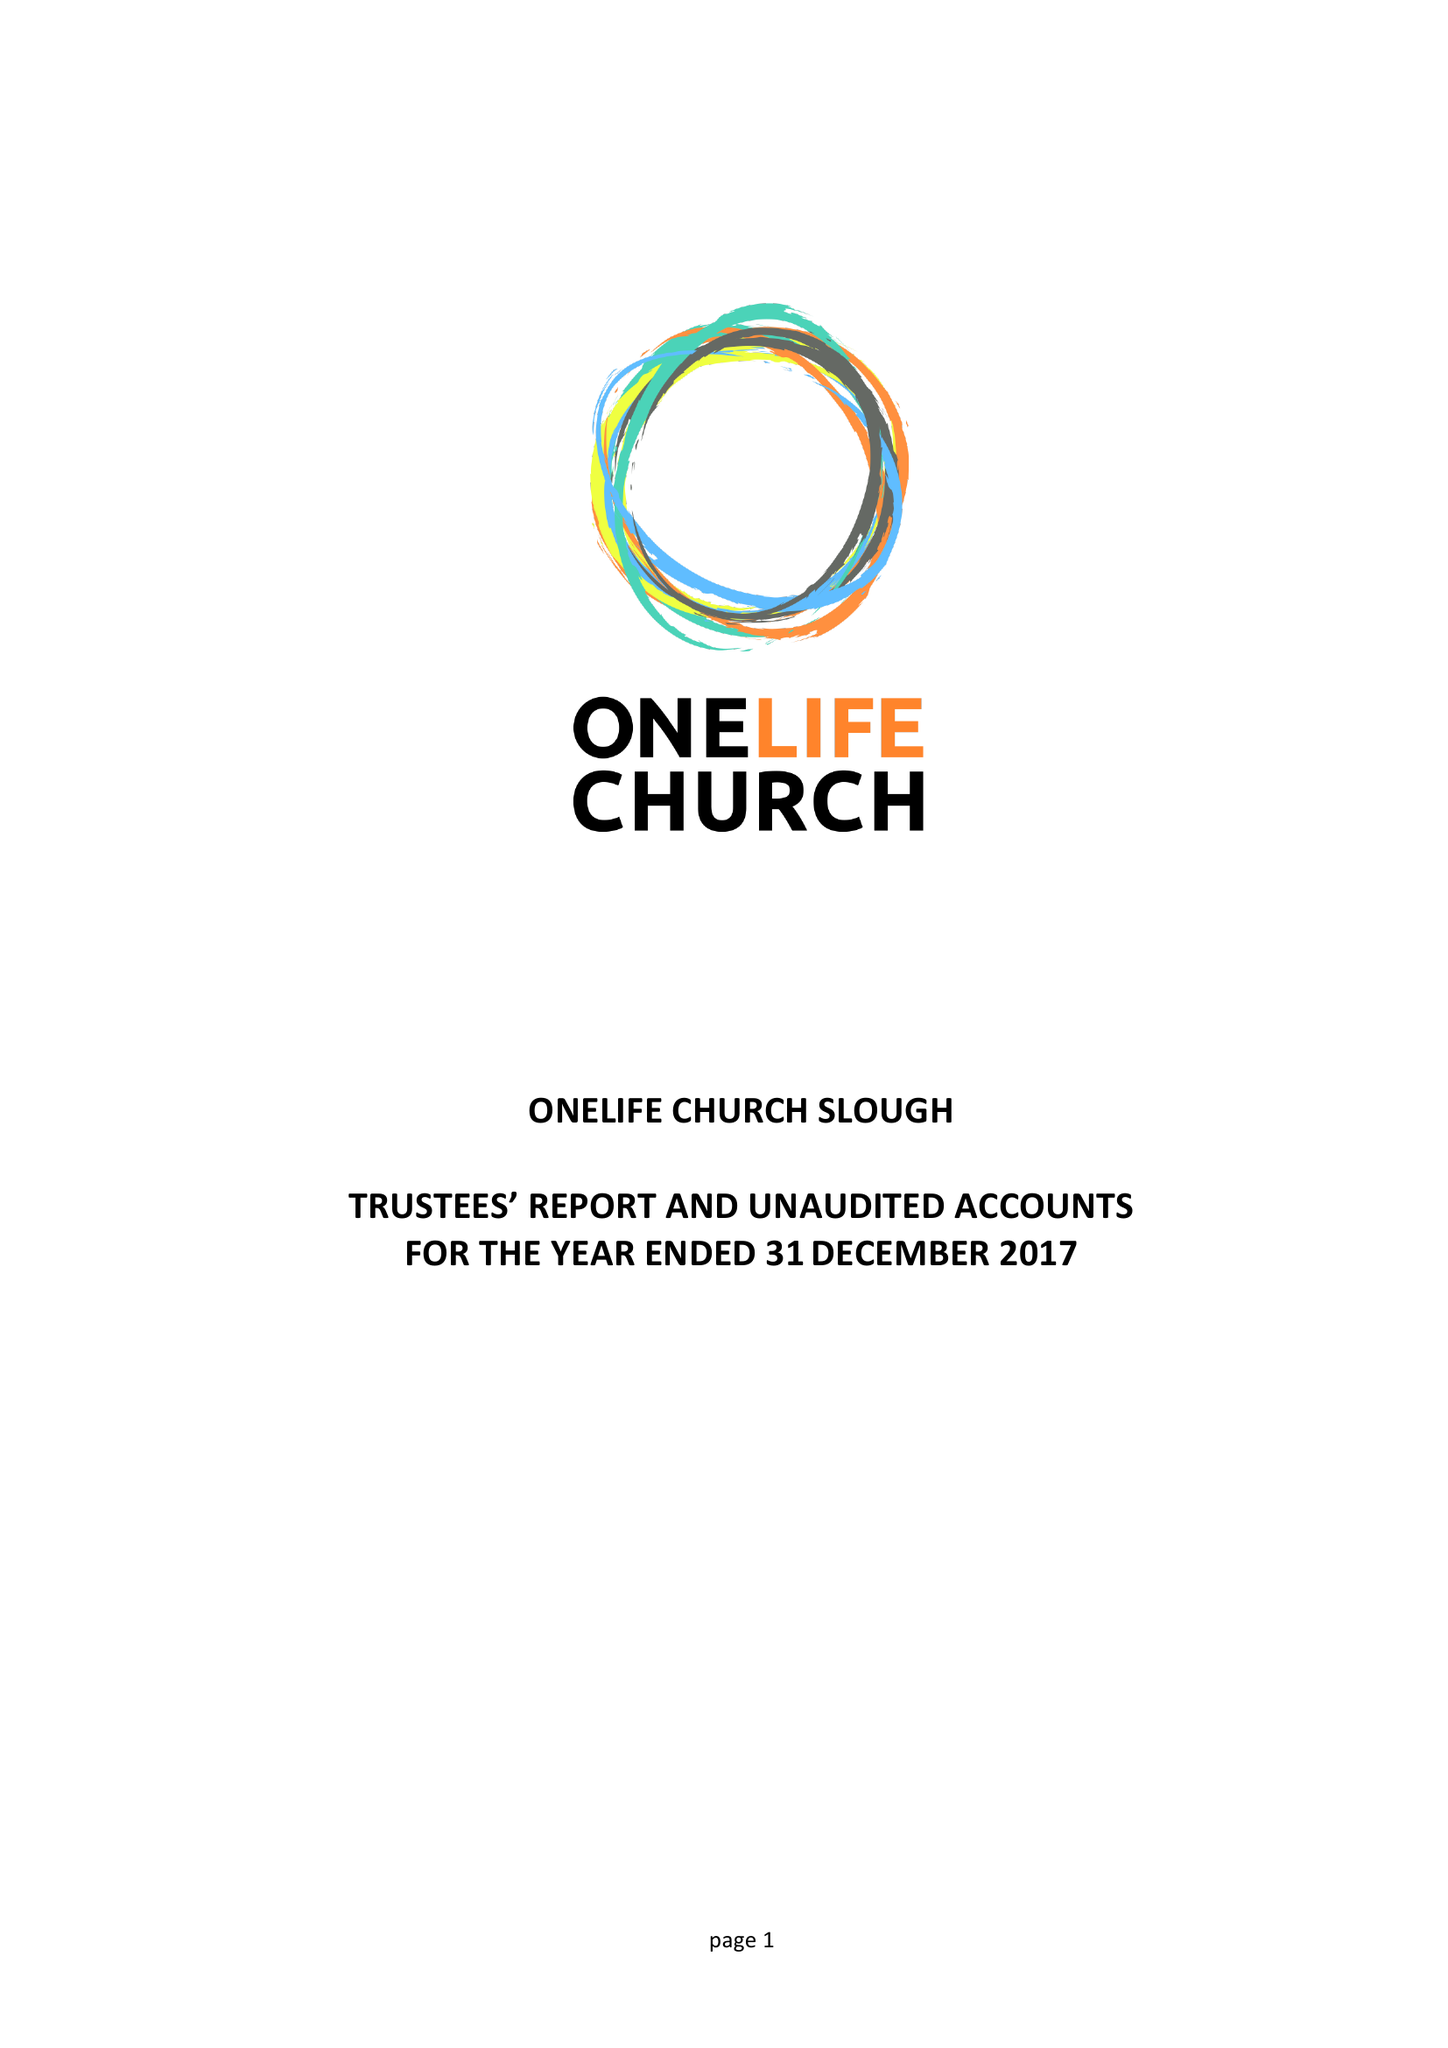What is the value for the address__street_line?
Answer the question using a single word or phrase. 306 SCAFELL ROAD 